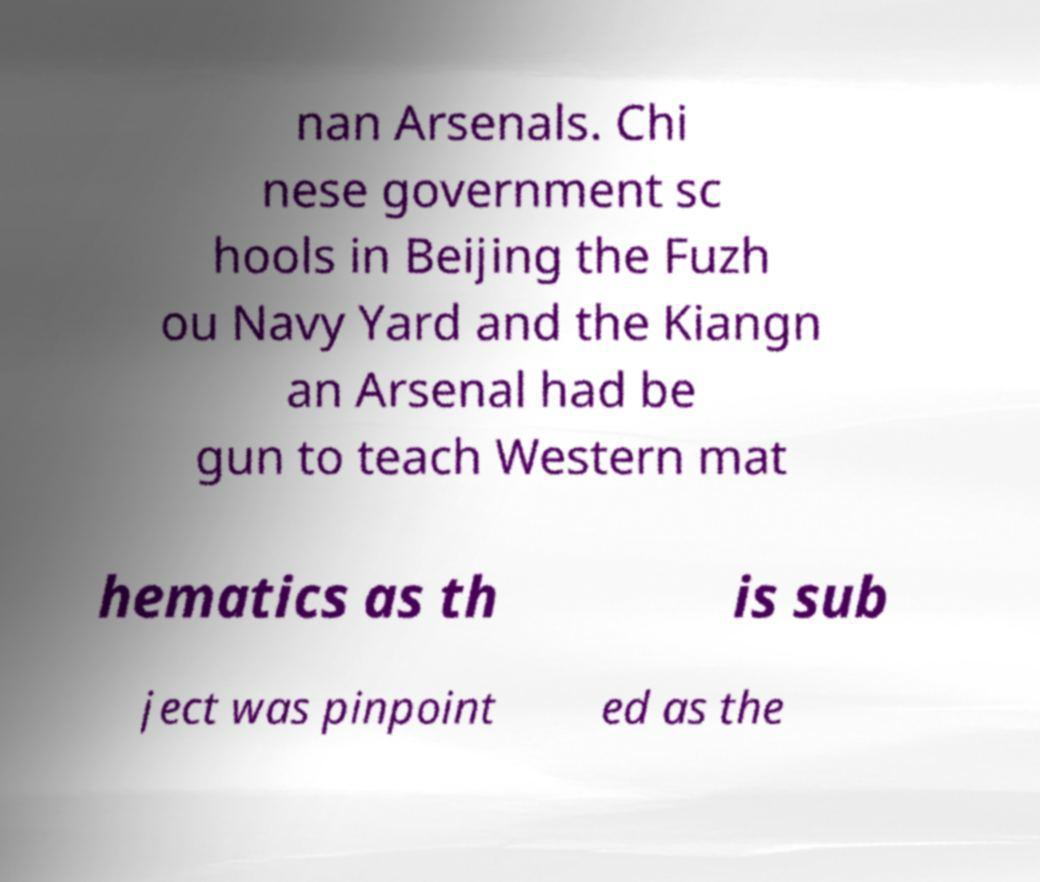For documentation purposes, I need the text within this image transcribed. Could you provide that? nan Arsenals. Chi nese government sc hools in Beijing the Fuzh ou Navy Yard and the Kiangn an Arsenal had be gun to teach Western mat hematics as th is sub ject was pinpoint ed as the 